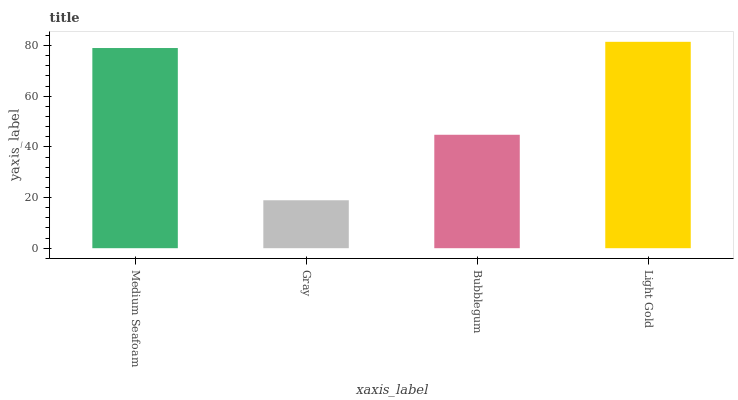Is Gray the minimum?
Answer yes or no. Yes. Is Light Gold the maximum?
Answer yes or no. Yes. Is Bubblegum the minimum?
Answer yes or no. No. Is Bubblegum the maximum?
Answer yes or no. No. Is Bubblegum greater than Gray?
Answer yes or no. Yes. Is Gray less than Bubblegum?
Answer yes or no. Yes. Is Gray greater than Bubblegum?
Answer yes or no. No. Is Bubblegum less than Gray?
Answer yes or no. No. Is Medium Seafoam the high median?
Answer yes or no. Yes. Is Bubblegum the low median?
Answer yes or no. Yes. Is Bubblegum the high median?
Answer yes or no. No. Is Medium Seafoam the low median?
Answer yes or no. No. 